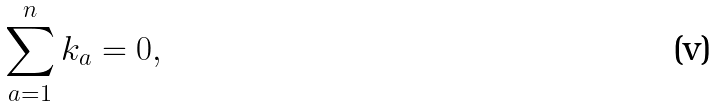Convert formula to latex. <formula><loc_0><loc_0><loc_500><loc_500>\sum _ { a = 1 } ^ { n } k _ { a } = 0 ,</formula> 